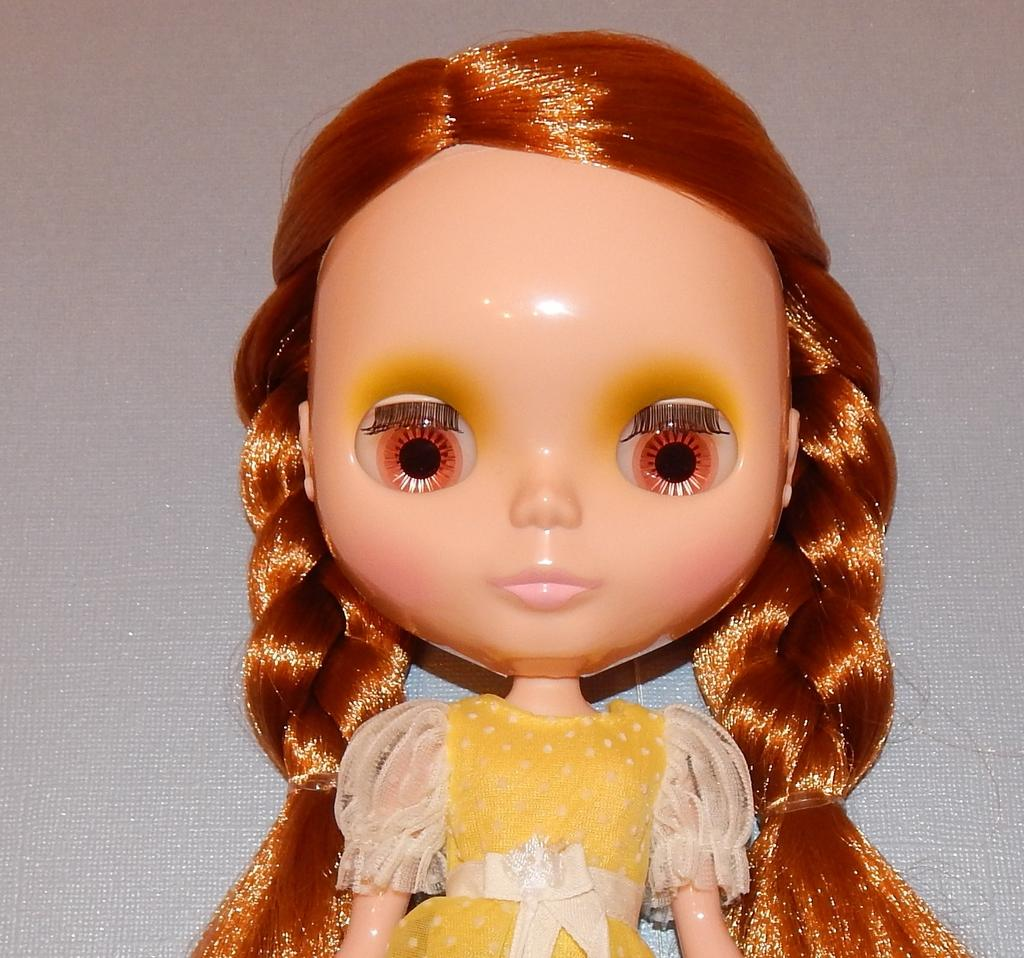What is placed on a surface in the image? There is a doll placed on a surface in the image. How many kittens are playing with the doll in the image? There are no kittens present in the image; it only features a doll placed on a surface. What time of day is depicted in the image? The provided facts do not mention the time of day, so it cannot be determined from the image. 